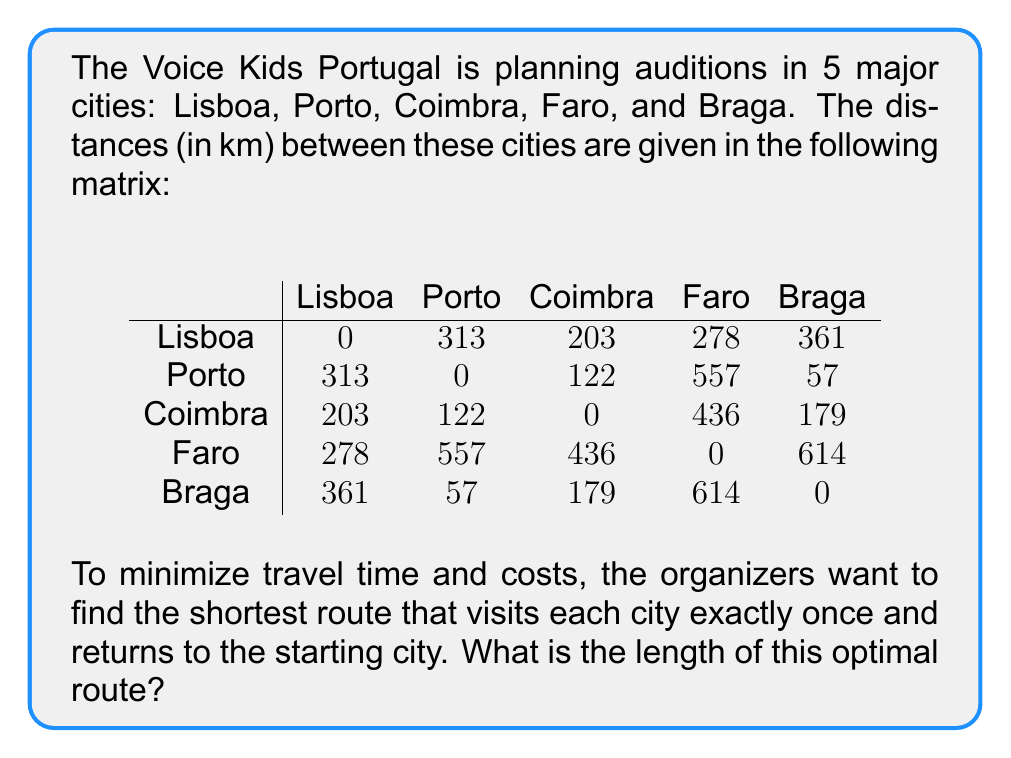Solve this math problem. This problem is a classic example of the Traveling Salesman Problem (TSP). To solve it, we'll use the following steps:

1) First, we need to identify all possible routes. With 5 cities, there are $(5-1)! = 24$ possible routes (we fix the starting city).

2) For each route, we calculate the total distance by adding up the distances between consecutive cities and the distance from the last city back to the first.

3) We then compare all these total distances to find the minimum.

Let's use Lisboa as our starting and ending point. Here are a few example calculations:

Route 1: Lisboa -> Porto -> Coimbra -> Faro -> Braga -> Lisboa
Distance = 313 + 122 + 436 + 614 + 361 = 1846 km

Route 2: Lisboa -> Faro -> Coimbra -> Porto -> Braga -> Lisboa
Distance = 278 + 436 + 122 + 57 + 361 = 1254 km

We would continue this process for all 24 possible routes.

4) After calculating all routes, we find that the shortest route is:

Lisboa -> Faro -> Coimbra -> Porto -> Braga -> Lisboa

5) The total distance of this optimal route is:
278 (Lisboa to Faro) + 
436 (Faro to Coimbra) + 
122 (Coimbra to Porto) + 
57 (Porto to Braga) + 
361 (Braga back to Lisboa) 
= 1254 km
Answer: The length of the optimal route is 1254 km. 